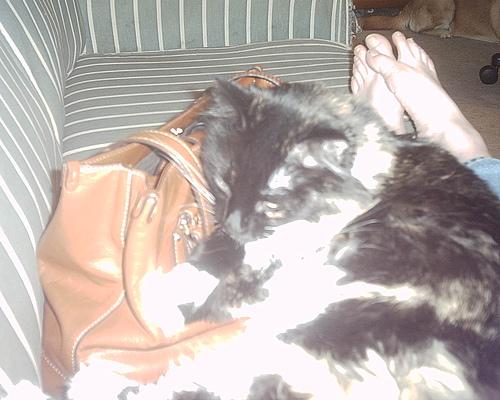What is the pattern on the sofa known as?
Give a very brief answer. Stripes. Is this a feline?
Be succinct. Yes. Is the picture overexposed?
Concise answer only. Yes. 